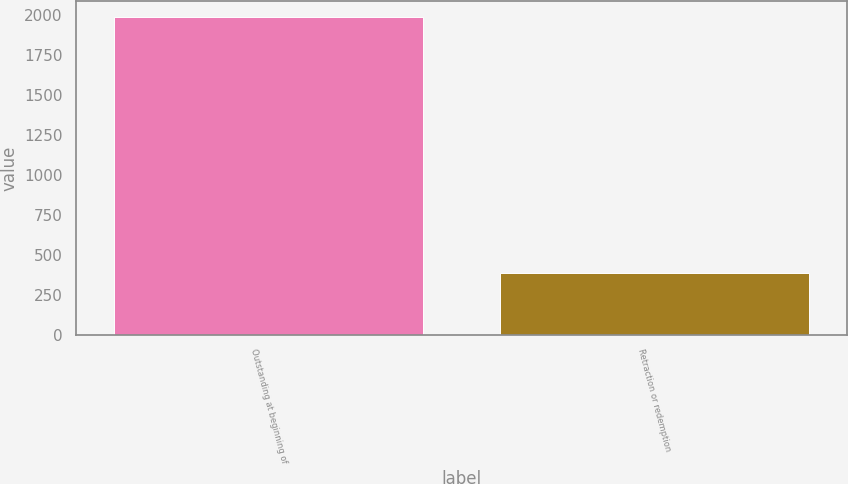Convert chart to OTSL. <chart><loc_0><loc_0><loc_500><loc_500><bar_chart><fcel>Outstanding at beginning of<fcel>Retraction or redemption<nl><fcel>1988<fcel>388<nl></chart> 